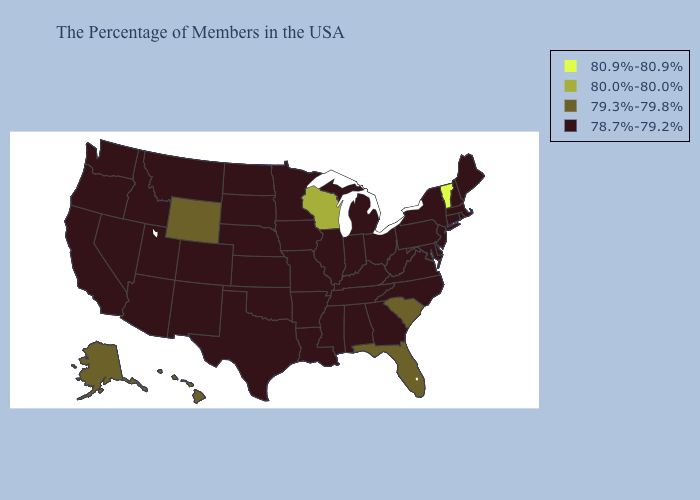Among the states that border Wyoming , which have the highest value?
Concise answer only. Nebraska, South Dakota, Colorado, Utah, Montana, Idaho. Does Nebraska have a lower value than Florida?
Quick response, please. Yes. Does Wisconsin have the lowest value in the MidWest?
Short answer required. No. Name the states that have a value in the range 80.0%-80.0%?
Keep it brief. Wisconsin. How many symbols are there in the legend?
Quick response, please. 4. Among the states that border Alabama , does Mississippi have the highest value?
Answer briefly. No. Name the states that have a value in the range 80.0%-80.0%?
Quick response, please. Wisconsin. What is the value of Wyoming?
Give a very brief answer. 79.3%-79.8%. Does Oregon have the highest value in the USA?
Be succinct. No. Among the states that border Montana , which have the highest value?
Keep it brief. Wyoming. What is the highest value in the South ?
Answer briefly. 79.3%-79.8%. Does the map have missing data?
Quick response, please. No. How many symbols are there in the legend?
Be succinct. 4. What is the value of Montana?
Answer briefly. 78.7%-79.2%. 